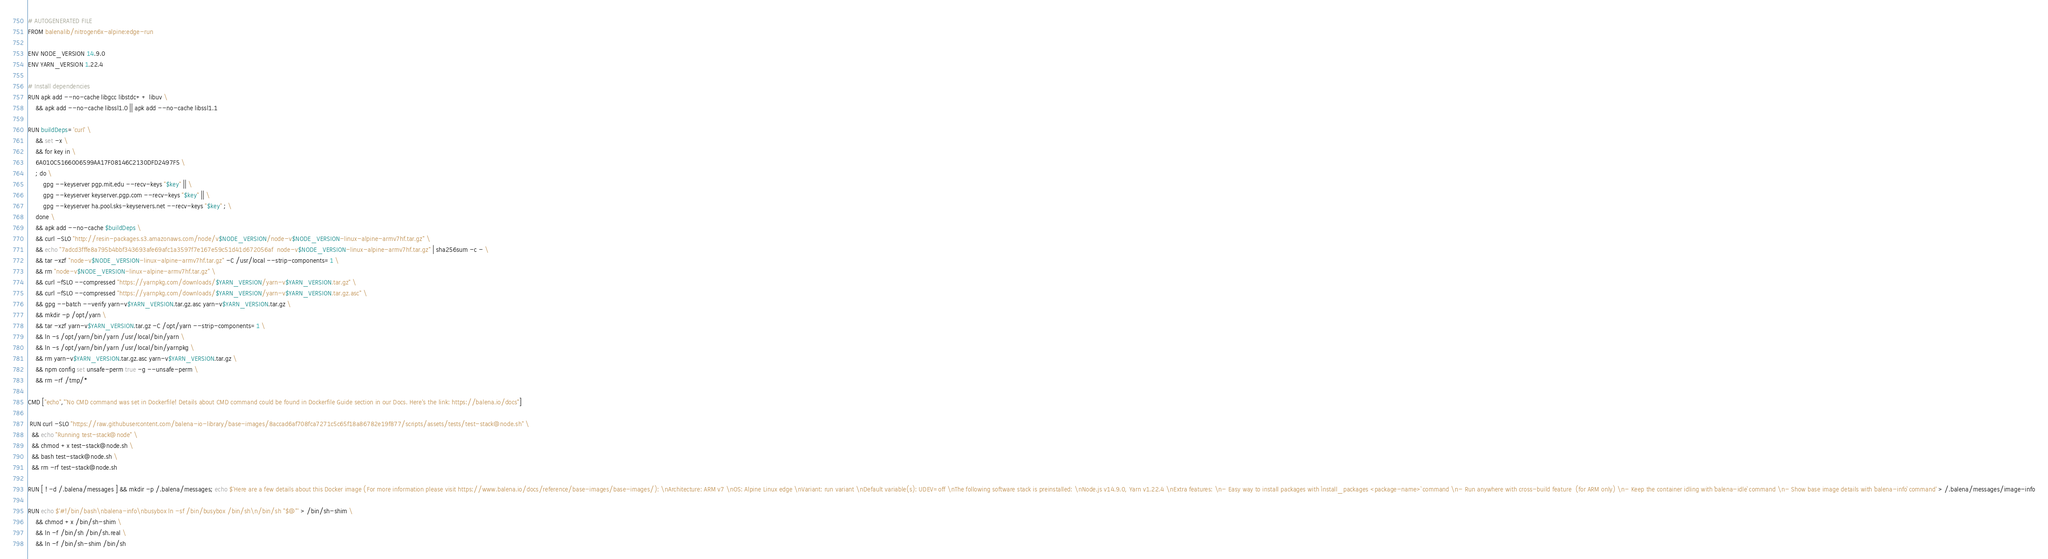Convert code to text. <code><loc_0><loc_0><loc_500><loc_500><_Dockerfile_># AUTOGENERATED FILE
FROM balenalib/nitrogen6x-alpine:edge-run

ENV NODE_VERSION 14.9.0
ENV YARN_VERSION 1.22.4

# Install dependencies
RUN apk add --no-cache libgcc libstdc++ libuv \
	&& apk add --no-cache libssl1.0 || apk add --no-cache libssl1.1

RUN buildDeps='curl' \
	&& set -x \
	&& for key in \
	6A010C5166006599AA17F08146C2130DFD2497F5 \
	; do \
		gpg --keyserver pgp.mit.edu --recv-keys "$key" || \
		gpg --keyserver keyserver.pgp.com --recv-keys "$key" || \
		gpg --keyserver ha.pool.sks-keyservers.net --recv-keys "$key" ; \
	done \
	&& apk add --no-cache $buildDeps \
	&& curl -SLO "http://resin-packages.s3.amazonaws.com/node/v$NODE_VERSION/node-v$NODE_VERSION-linux-alpine-armv7hf.tar.gz" \
	&& echo "7adcd3fffe8a795b4bbf343693afe69afc1a3597f7e167e59c51d41d672056af  node-v$NODE_VERSION-linux-alpine-armv7hf.tar.gz" | sha256sum -c - \
	&& tar -xzf "node-v$NODE_VERSION-linux-alpine-armv7hf.tar.gz" -C /usr/local --strip-components=1 \
	&& rm "node-v$NODE_VERSION-linux-alpine-armv7hf.tar.gz" \
	&& curl -fSLO --compressed "https://yarnpkg.com/downloads/$YARN_VERSION/yarn-v$YARN_VERSION.tar.gz" \
	&& curl -fSLO --compressed "https://yarnpkg.com/downloads/$YARN_VERSION/yarn-v$YARN_VERSION.tar.gz.asc" \
	&& gpg --batch --verify yarn-v$YARN_VERSION.tar.gz.asc yarn-v$YARN_VERSION.tar.gz \
	&& mkdir -p /opt/yarn \
	&& tar -xzf yarn-v$YARN_VERSION.tar.gz -C /opt/yarn --strip-components=1 \
	&& ln -s /opt/yarn/bin/yarn /usr/local/bin/yarn \
	&& ln -s /opt/yarn/bin/yarn /usr/local/bin/yarnpkg \
	&& rm yarn-v$YARN_VERSION.tar.gz.asc yarn-v$YARN_VERSION.tar.gz \
	&& npm config set unsafe-perm true -g --unsafe-perm \
	&& rm -rf /tmp/*

CMD ["echo","'No CMD command was set in Dockerfile! Details about CMD command could be found in Dockerfile Guide section in our Docs. Here's the link: https://balena.io/docs"]

 RUN curl -SLO "https://raw.githubusercontent.com/balena-io-library/base-images/8accad6af708fca7271c5c65f18a86782e19f877/scripts/assets/tests/test-stack@node.sh" \
  && echo "Running test-stack@node" \
  && chmod +x test-stack@node.sh \
  && bash test-stack@node.sh \
  && rm -rf test-stack@node.sh 

RUN [ ! -d /.balena/messages ] && mkdir -p /.balena/messages; echo $'Here are a few details about this Docker image (For more information please visit https://www.balena.io/docs/reference/base-images/base-images/): \nArchitecture: ARM v7 \nOS: Alpine Linux edge \nVariant: run variant \nDefault variable(s): UDEV=off \nThe following software stack is preinstalled: \nNode.js v14.9.0, Yarn v1.22.4 \nExtra features: \n- Easy way to install packages with `install_packages <package-name>` command \n- Run anywhere with cross-build feature  (for ARM only) \n- Keep the container idling with `balena-idle` command \n- Show base image details with `balena-info` command' > /.balena/messages/image-info

RUN echo $'#!/bin/bash\nbalena-info\nbusybox ln -sf /bin/busybox /bin/sh\n/bin/sh "$@"' > /bin/sh-shim \
	&& chmod +x /bin/sh-shim \
	&& ln -f /bin/sh /bin/sh.real \
	&& ln -f /bin/sh-shim /bin/sh</code> 